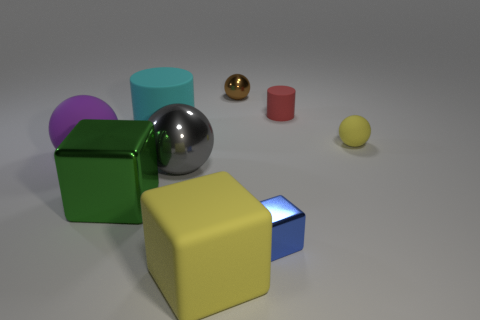Subtract all large metal things. Subtract all cylinders. How many objects are left? 5 Add 9 large rubber cylinders. How many large rubber cylinders are left? 10 Add 3 metallic balls. How many metallic balls exist? 5 Subtract all cyan cylinders. How many cylinders are left? 1 Subtract all metallic cubes. How many cubes are left? 1 Subtract 0 brown blocks. How many objects are left? 9 Subtract all spheres. How many objects are left? 5 Subtract 3 blocks. How many blocks are left? 0 Subtract all yellow balls. Subtract all purple cylinders. How many balls are left? 3 Subtract all cyan blocks. How many red spheres are left? 0 